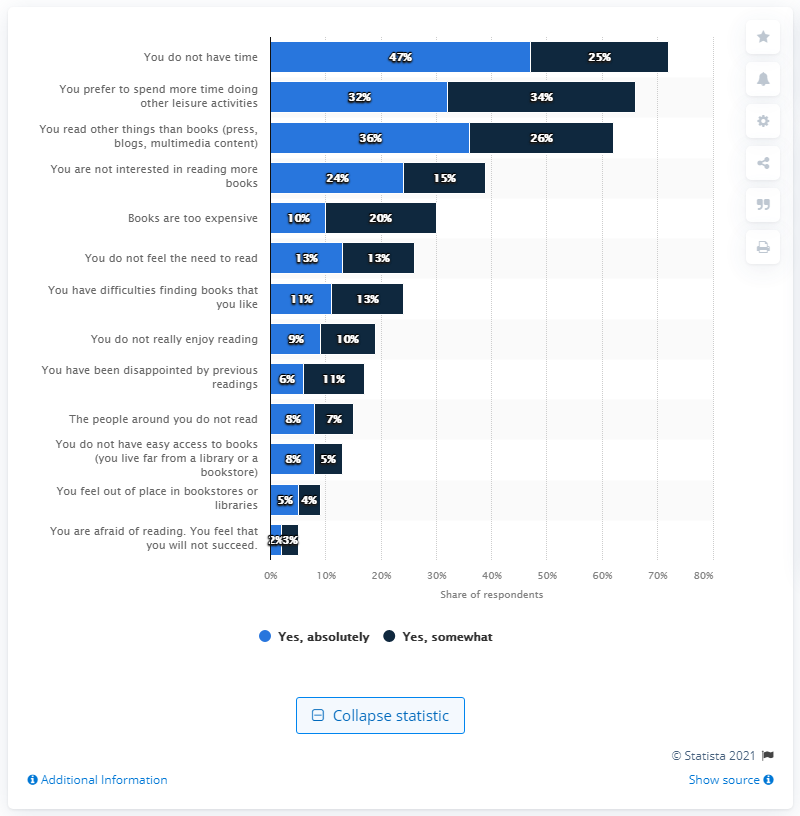Specify some key components in this picture. Out of all responses given, the highest percentage of respondents answered 'yes, absolutely' at 47%. 